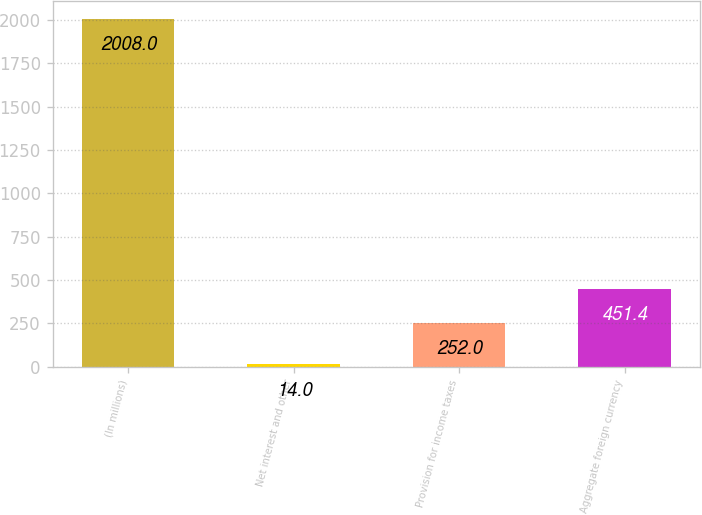<chart> <loc_0><loc_0><loc_500><loc_500><bar_chart><fcel>(In millions)<fcel>Net interest and other<fcel>Provision for income taxes<fcel>Aggregate foreign currency<nl><fcel>2008<fcel>14<fcel>252<fcel>451.4<nl></chart> 